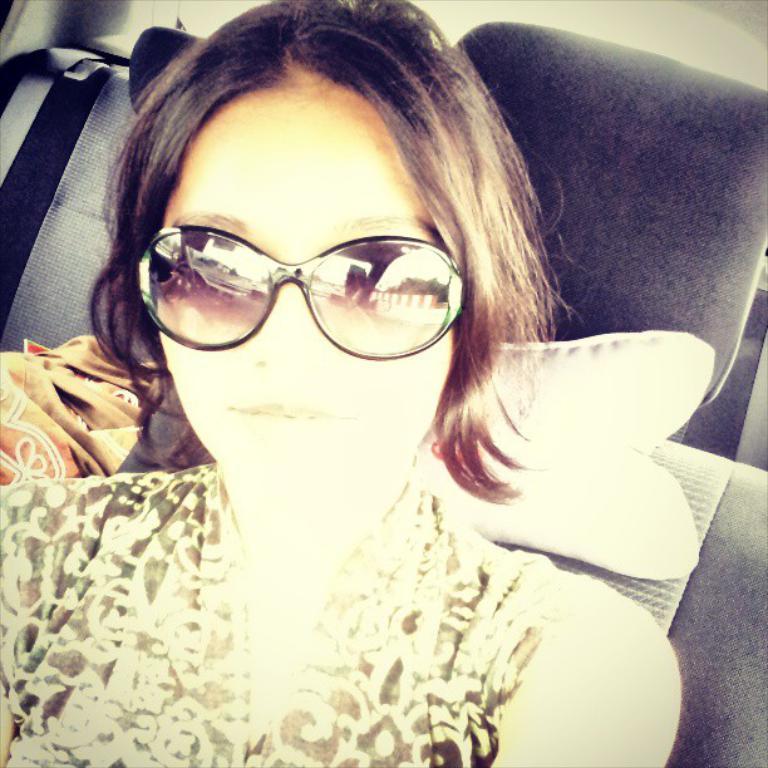Please provide a concise description of this image. A beautiful girl is sitting in the vehicle, she wore dress, spectacles. 